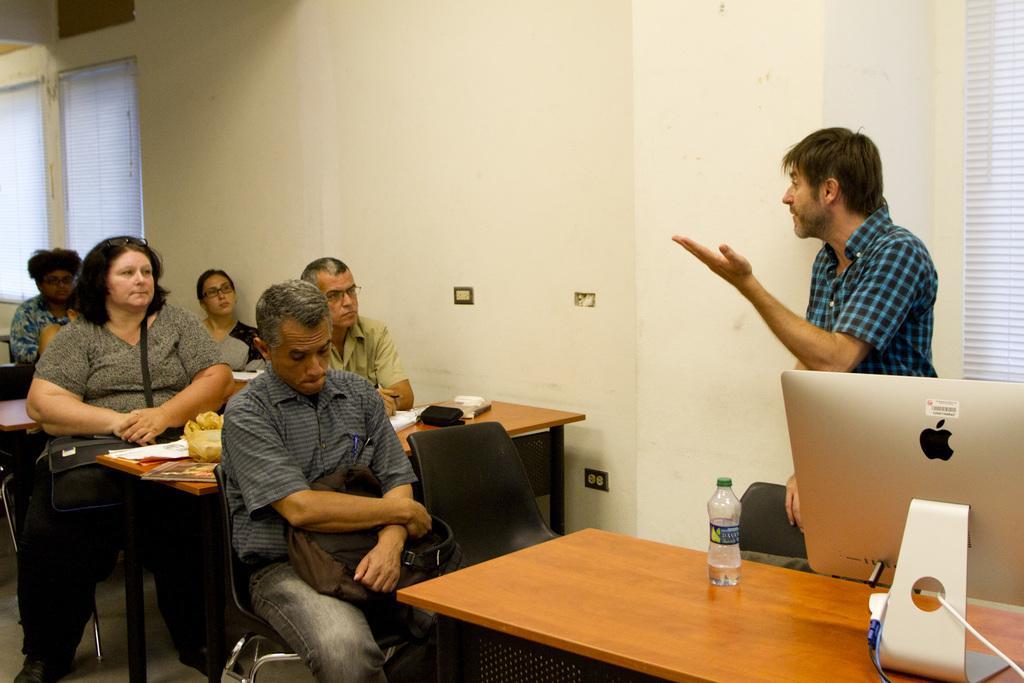Please provide a concise description of this image. Here we can see some persons are sitting on the chairs. These are the tables. On the table there are books and bottle. This is monitor. Here we can see a man who is standing on the floor. On the background there is a wall and this is window. 